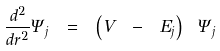Convert formula to latex. <formula><loc_0><loc_0><loc_500><loc_500>\frac { d ^ { 2 } } { d r ^ { 2 } } \Psi _ { j } \ = \ \left ( V \ - \ E _ { j } \right ) \ \Psi _ { j }</formula> 